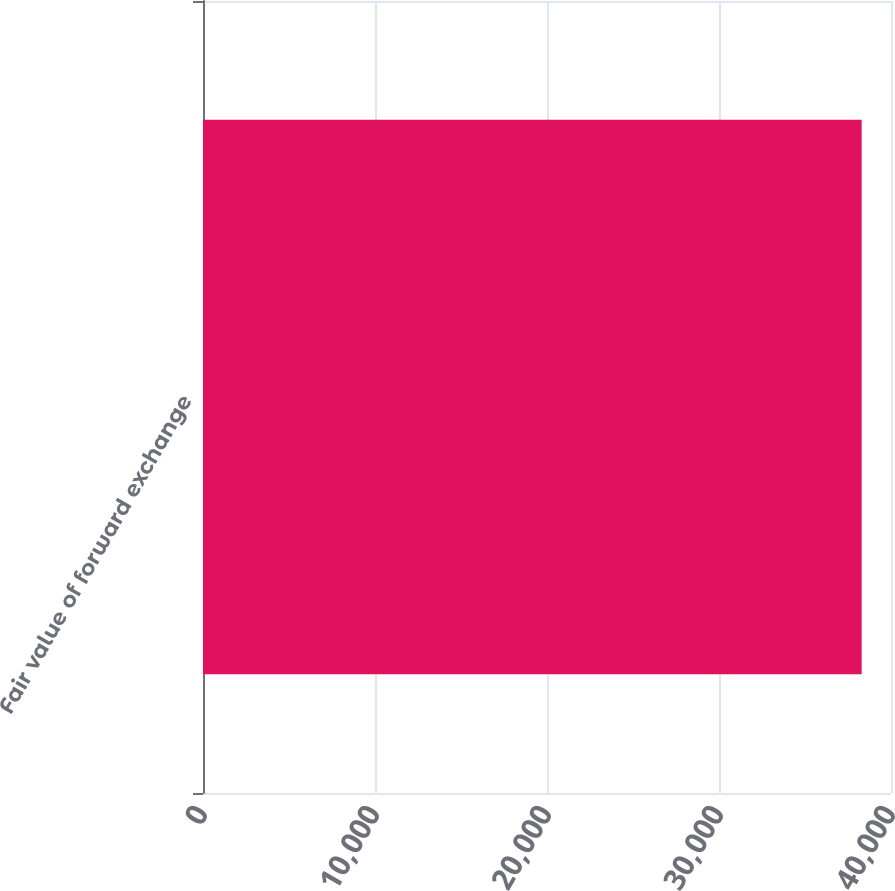Convert chart to OTSL. <chart><loc_0><loc_0><loc_500><loc_500><bar_chart><fcel>Fair value of forward exchange<nl><fcel>38294<nl></chart> 